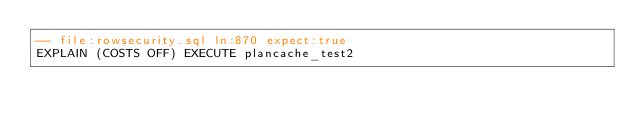Convert code to text. <code><loc_0><loc_0><loc_500><loc_500><_SQL_>-- file:rowsecurity.sql ln:870 expect:true
EXPLAIN (COSTS OFF) EXECUTE plancache_test2
</code> 